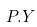Convert formula to latex. <formula><loc_0><loc_0><loc_500><loc_500>P . Y</formula> 